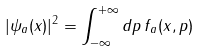Convert formula to latex. <formula><loc_0><loc_0><loc_500><loc_500>| \psi _ { a } ( x ) | ^ { 2 } = \int _ { - \infty } ^ { + \infty } d p \, f _ { a } ( x , p )</formula> 